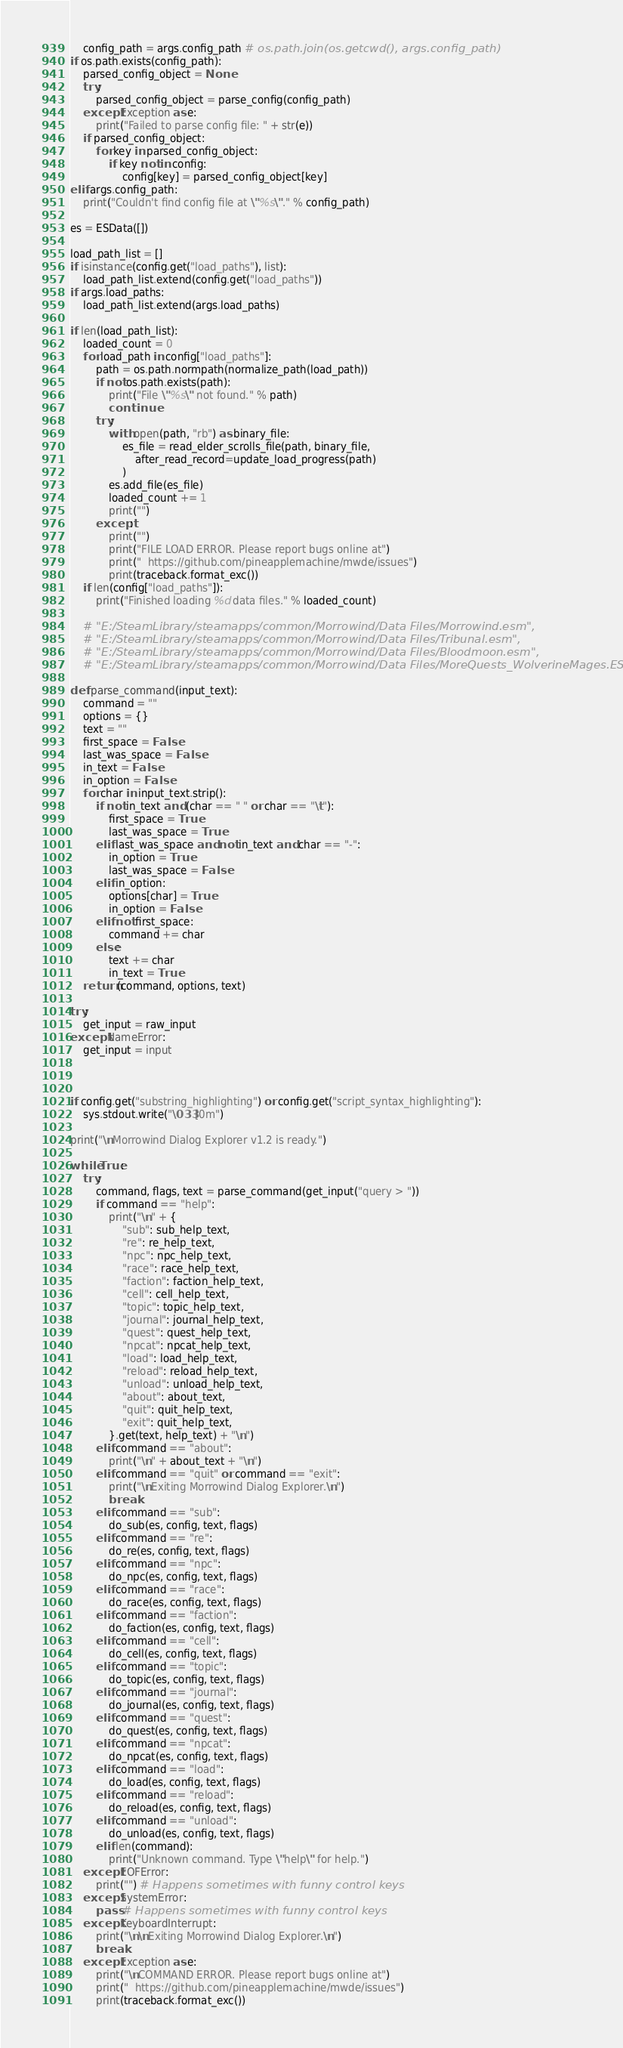<code> <loc_0><loc_0><loc_500><loc_500><_Python_>    config_path = args.config_path # os.path.join(os.getcwd(), args.config_path)
if os.path.exists(config_path):
    parsed_config_object = None
    try:
        parsed_config_object = parse_config(config_path)
    except Exception as e:
        print("Failed to parse config file: " + str(e))
    if parsed_config_object:
        for key in parsed_config_object:
            if key not in config:
                config[key] = parsed_config_object[key]
elif args.config_path:
    print("Couldn't find config file at \"%s\"." % config_path)

es = ESData([])

load_path_list = []
if isinstance(config.get("load_paths"), list):
    load_path_list.extend(config.get("load_paths"))
if args.load_paths:
    load_path_list.extend(args.load_paths)

if len(load_path_list):
    loaded_count = 0
    for load_path in config["load_paths"]:
        path = os.path.normpath(normalize_path(load_path))
        if not os.path.exists(path):
            print("File \"%s\" not found." % path)
            continue
        try:
            with open(path, "rb") as binary_file:
                es_file = read_elder_scrolls_file(path, binary_file,
                    after_read_record=update_load_progress(path)
                )
            es.add_file(es_file)
            loaded_count += 1
            print("")
        except:
            print("")
            print("FILE LOAD ERROR. Please report bugs online at")
            print("  https://github.com/pineapplemachine/mwde/issues")
            print(traceback.format_exc())
    if len(config["load_paths"]):
        print("Finished loading %d data files." % loaded_count)

    # "E:/SteamLibrary/steamapps/common/Morrowind/Data Files/Morrowind.esm",
    # "E:/SteamLibrary/steamapps/common/Morrowind/Data Files/Tribunal.esm",
    # "E:/SteamLibrary/steamapps/common/Morrowind/Data Files/Bloodmoon.esm",
    # "E:/SteamLibrary/steamapps/common/Morrowind/Data Files/MoreQuests_WolverineMages.ESP",

def parse_command(input_text):
    command = ""
    options = {}
    text = ""
    first_space = False
    last_was_space = False
    in_text = False
    in_option = False
    for char in input_text.strip():
        if not in_text and (char == " " or char == "\t"):
            first_space = True
            last_was_space = True
        elif last_was_space and not in_text and char == "-":
            in_option = True
            last_was_space = False
        elif in_option:
            options[char] = True
            in_option = False
        elif not first_space:
            command += char
        else:
            text += char
            in_text = True
    return (command, options, text)

try:
    get_input = raw_input
except NameError:
    get_input = input



if config.get("substring_highlighting") or config.get("script_syntax_highlighting"):
    sys.stdout.write("\033[0m")

print("\nMorrowind Dialog Explorer v1.2 is ready.")

while True:
    try:
        command, flags, text = parse_command(get_input("query > "))
        if command == "help":
            print("\n" + {
                "sub": sub_help_text,
                "re": re_help_text,
                "npc": npc_help_text,
                "race": race_help_text,
                "faction": faction_help_text,
                "cell": cell_help_text,
                "topic": topic_help_text,
                "journal": journal_help_text,
                "quest": quest_help_text,
                "npcat": npcat_help_text,
                "load": load_help_text,
                "reload": reload_help_text,
                "unload": unload_help_text,
                "about": about_text,
                "quit": quit_help_text,
                "exit": quit_help_text,
            }.get(text, help_text) + "\n")
        elif command == "about":
            print("\n" + about_text + "\n")
        elif command == "quit" or command == "exit":
            print("\nExiting Morrowind Dialog Explorer.\n")
            break
        elif command == "sub":
            do_sub(es, config, text, flags)
        elif command == "re":
            do_re(es, config, text, flags)
        elif command == "npc":
            do_npc(es, config, text, flags)
        elif command == "race":
            do_race(es, config, text, flags)
        elif command == "faction":
            do_faction(es, config, text, flags)
        elif command == "cell":
            do_cell(es, config, text, flags)
        elif command == "topic":
            do_topic(es, config, text, flags)
        elif command == "journal":
            do_journal(es, config, text, flags)
        elif command == "quest":
            do_quest(es, config, text, flags)
        elif command == "npcat":
            do_npcat(es, config, text, flags)
        elif command == "load":
            do_load(es, config, text, flags)
        elif command == "reload":
            do_reload(es, config, text, flags)
        elif command == "unload":
            do_unload(es, config, text, flags)
        elif len(command):
            print("Unknown command. Type \"help\" for help.")
    except EOFError:
        print("") # Happens sometimes with funny control keys
    except SystemError:
        pass # Happens sometimes with funny control keys
    except KeyboardInterrupt:
        print("\n\nExiting Morrowind Dialog Explorer.\n")
        break
    except Exception as e:
        print("\nCOMMAND ERROR. Please report bugs online at")
        print("  https://github.com/pineapplemachine/mwde/issues")
        print(traceback.format_exc())
</code> 